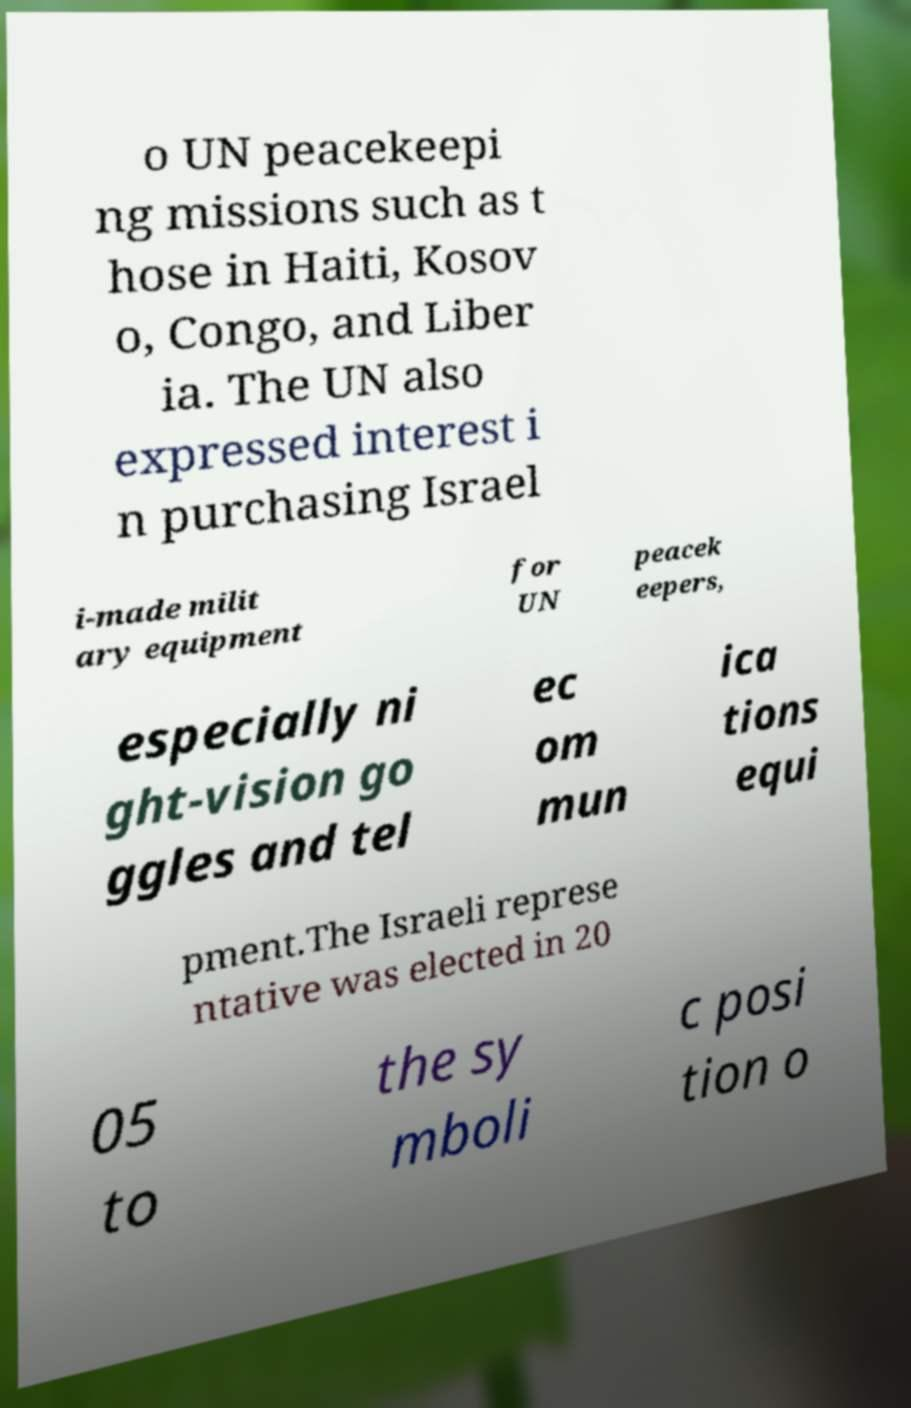Please read and relay the text visible in this image. What does it say? o UN peacekeepi ng missions such as t hose in Haiti, Kosov o, Congo, and Liber ia. The UN also expressed interest i n purchasing Israel i-made milit ary equipment for UN peacek eepers, especially ni ght-vision go ggles and tel ec om mun ica tions equi pment.The Israeli represe ntative was elected in 20 05 to the sy mboli c posi tion o 